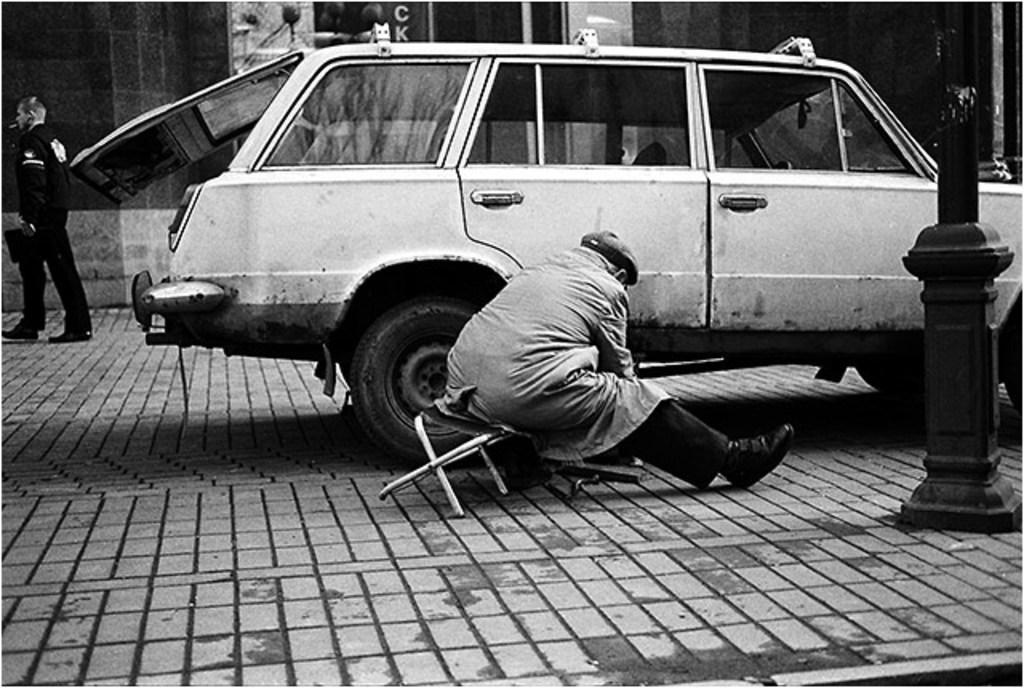Please provide a concise description of this image. This is a black and white picture. Here we can see a vehicle, pole, and two persons. In the background we can see wall. 